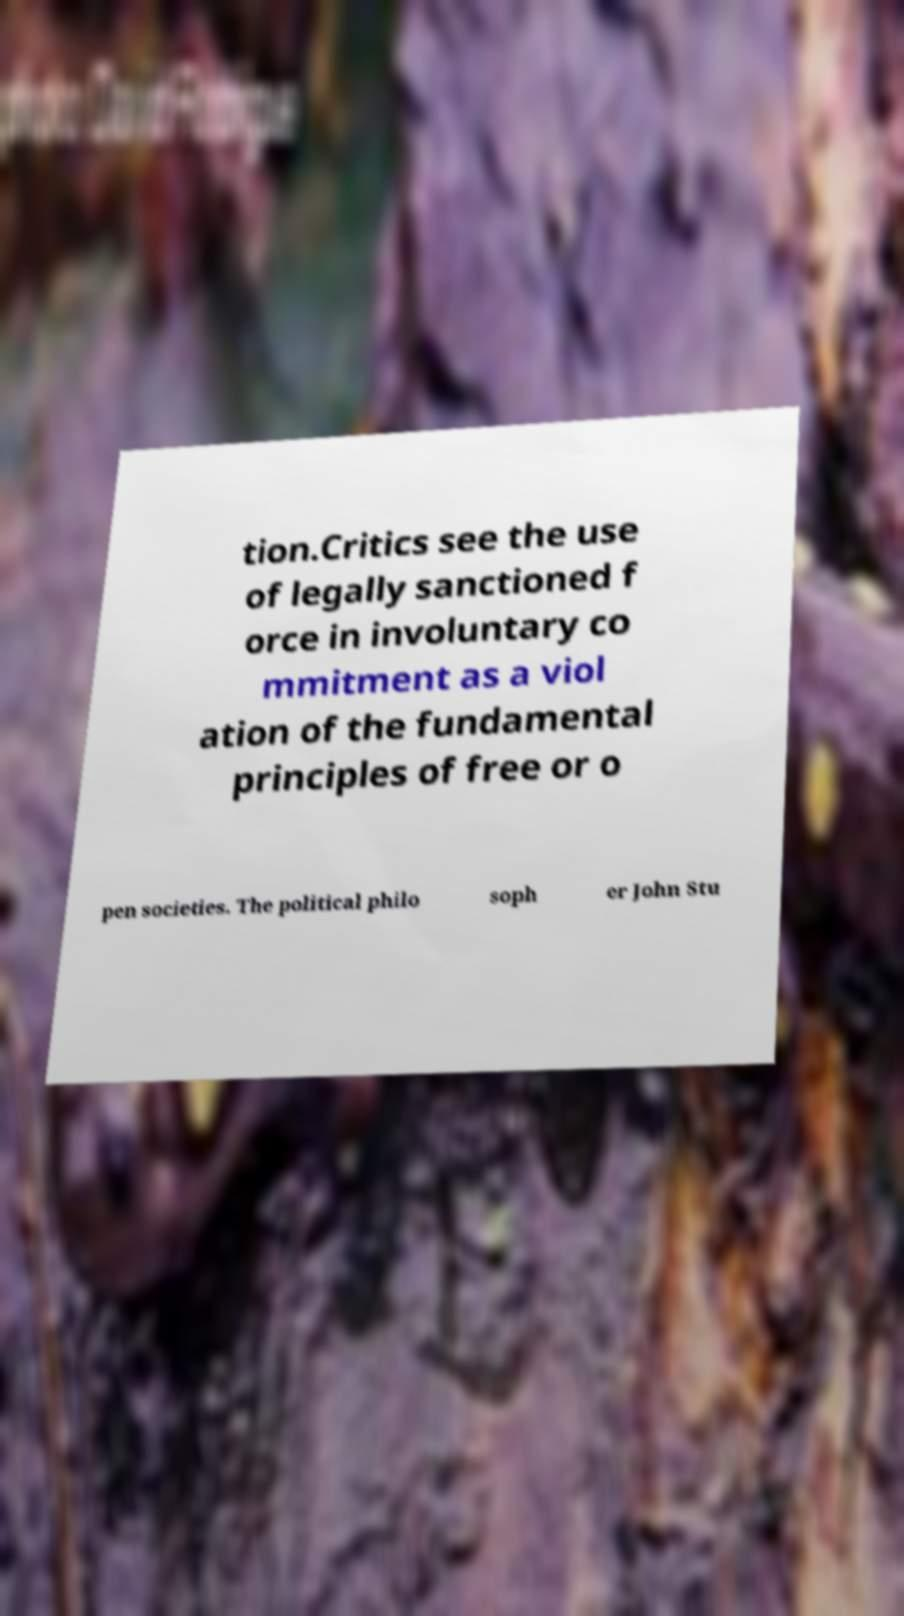Could you extract and type out the text from this image? tion.Critics see the use of legally sanctioned f orce in involuntary co mmitment as a viol ation of the fundamental principles of free or o pen societies. The political philo soph er John Stu 